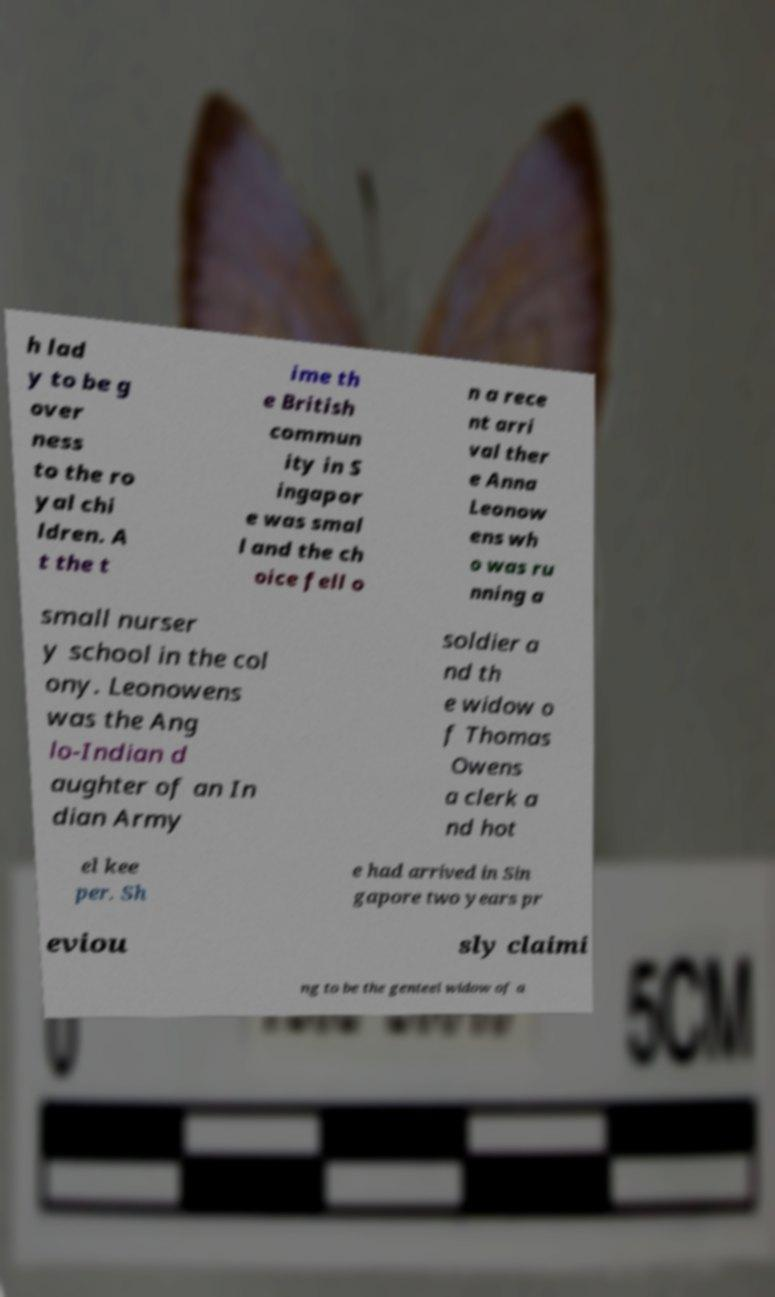Can you read and provide the text displayed in the image?This photo seems to have some interesting text. Can you extract and type it out for me? h lad y to be g over ness to the ro yal chi ldren. A t the t ime th e British commun ity in S ingapor e was smal l and the ch oice fell o n a rece nt arri val ther e Anna Leonow ens wh o was ru nning a small nurser y school in the col ony. Leonowens was the Ang lo-Indian d aughter of an In dian Army soldier a nd th e widow o f Thomas Owens a clerk a nd hot el kee per. Sh e had arrived in Sin gapore two years pr eviou sly claimi ng to be the genteel widow of a 